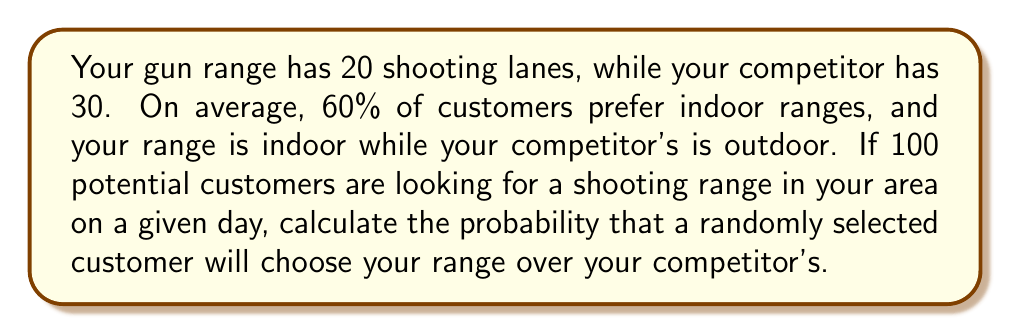Can you solve this math problem? Let's approach this step-by-step:

1) First, we need to calculate the probability of a customer choosing an indoor range:
   $P(\text{Indoor}) = 0.60$

2) The probability of choosing an outdoor range is the complement:
   $P(\text{Outdoor}) = 1 - P(\text{Indoor}) = 0.40$

3) Now, let's consider the number of lanes as a factor. The total number of lanes is:
   $\text{Total lanes} = 20 + 30 = 50$

4) The probability of choosing your range given that a customer prefers indoor ranges is:
   $P(\text{Your range | Indoor}) = \frac{20}{20} = 1$

5) The probability of choosing your range given that a customer prefers outdoor ranges is:
   $P(\text{Your range | Outdoor}) = 0$

6) We can now use the law of total probability:

   $$P(\text{Your range}) = P(\text{Your range | Indoor}) \cdot P(\text{Indoor}) + P(\text{Your range | Outdoor}) \cdot P(\text{Outdoor})$$

7) Substituting the values:

   $$P(\text{Your range}) = 1 \cdot 0.60 + 0 \cdot 0.40 = 0.60$$

Therefore, the probability that a randomly selected customer will choose your range is 0.60 or 60%.
Answer: 0.60 